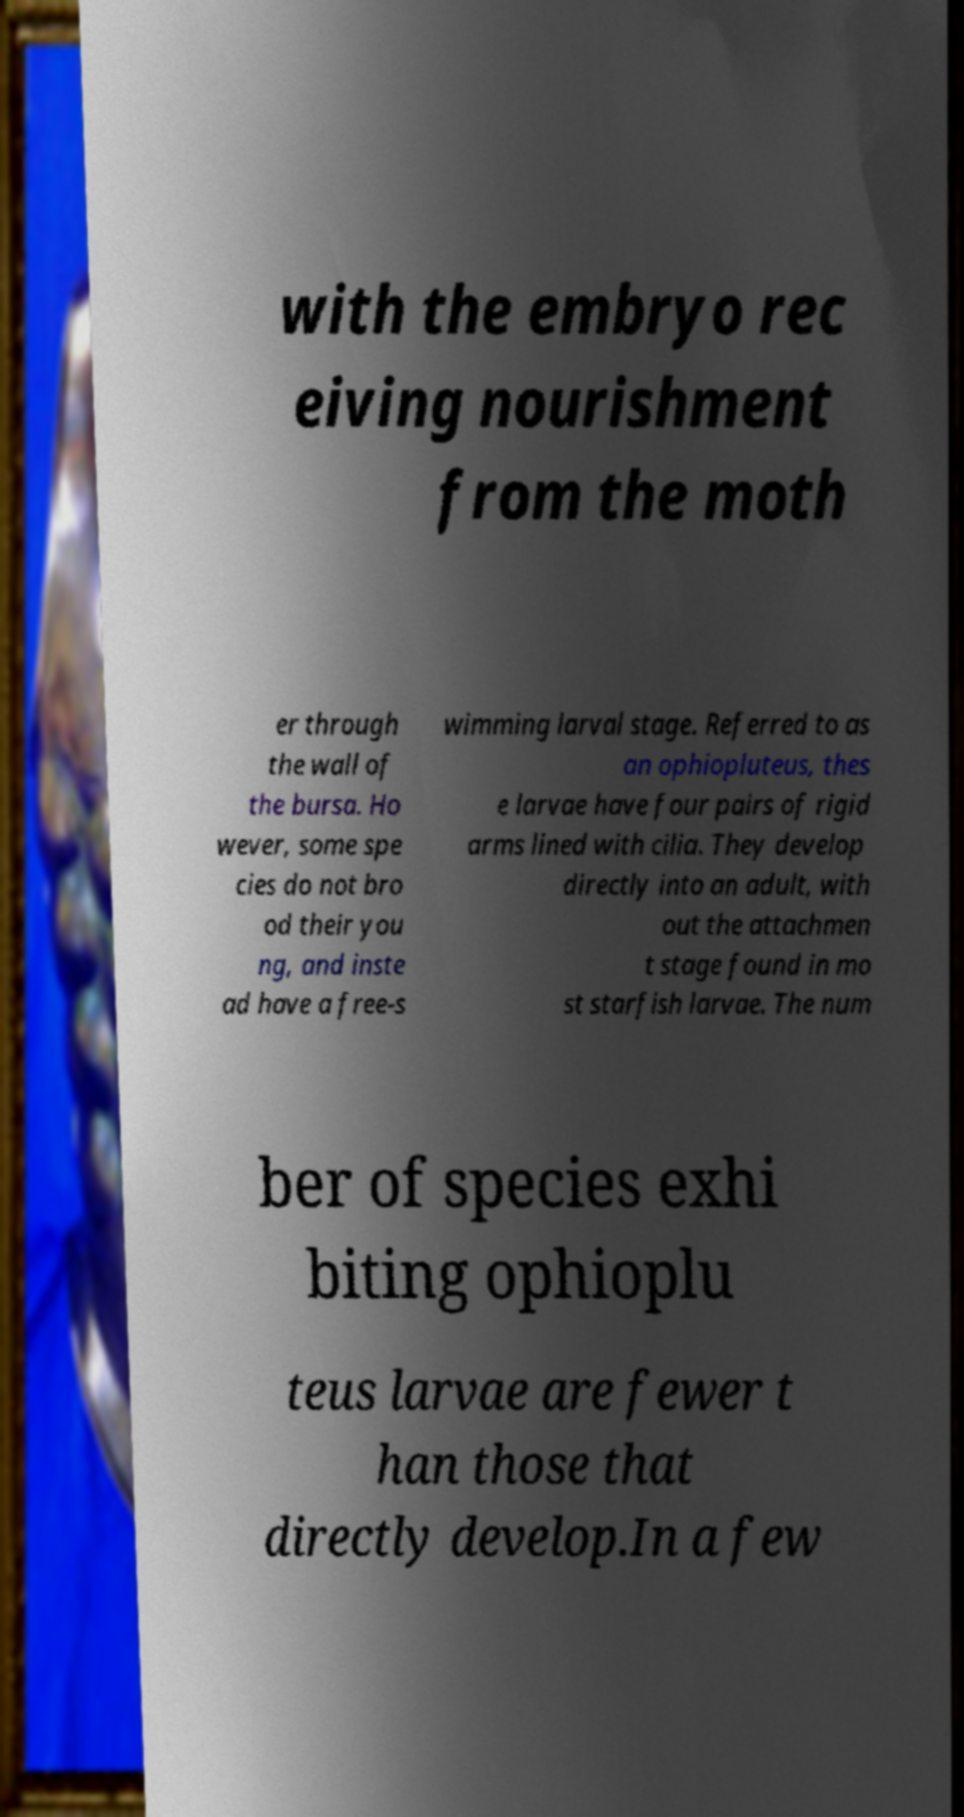Can you read and provide the text displayed in the image?This photo seems to have some interesting text. Can you extract and type it out for me? with the embryo rec eiving nourishment from the moth er through the wall of the bursa. Ho wever, some spe cies do not bro od their you ng, and inste ad have a free-s wimming larval stage. Referred to as an ophiopluteus, thes e larvae have four pairs of rigid arms lined with cilia. They develop directly into an adult, with out the attachmen t stage found in mo st starfish larvae. The num ber of species exhi biting ophioplu teus larvae are fewer t han those that directly develop.In a few 